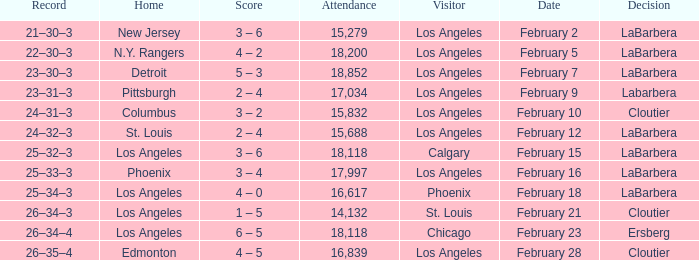What was the decision of the Kings game when Chicago was the visiting team? Ersberg. 